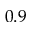Convert formula to latex. <formula><loc_0><loc_0><loc_500><loc_500>0 . 9</formula> 